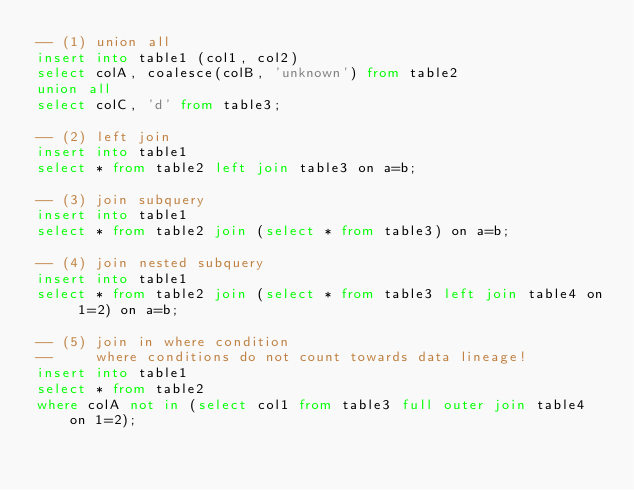Convert code to text. <code><loc_0><loc_0><loc_500><loc_500><_SQL_>-- (1) union all
insert into table1 (col1, col2)
select colA, coalesce(colB, 'unknown') from table2 
union all 
select colC, 'd' from table3;

-- (2) left join
insert into table1
select * from table2 left join table3 on a=b;

-- (3) join subquery
insert into table1
select * from table2 join (select * from table3) on a=b;

-- (4) join nested subquery
insert into table1
select * from table2 join (select * from table3 left join table4 on 1=2) on a=b;

-- (5) join in where condition
--     where conditions do not count towards data lineage!
insert into table1
select * from table2 
where colA not in (select col1 from table3 full outer join table4 on 1=2);
</code> 